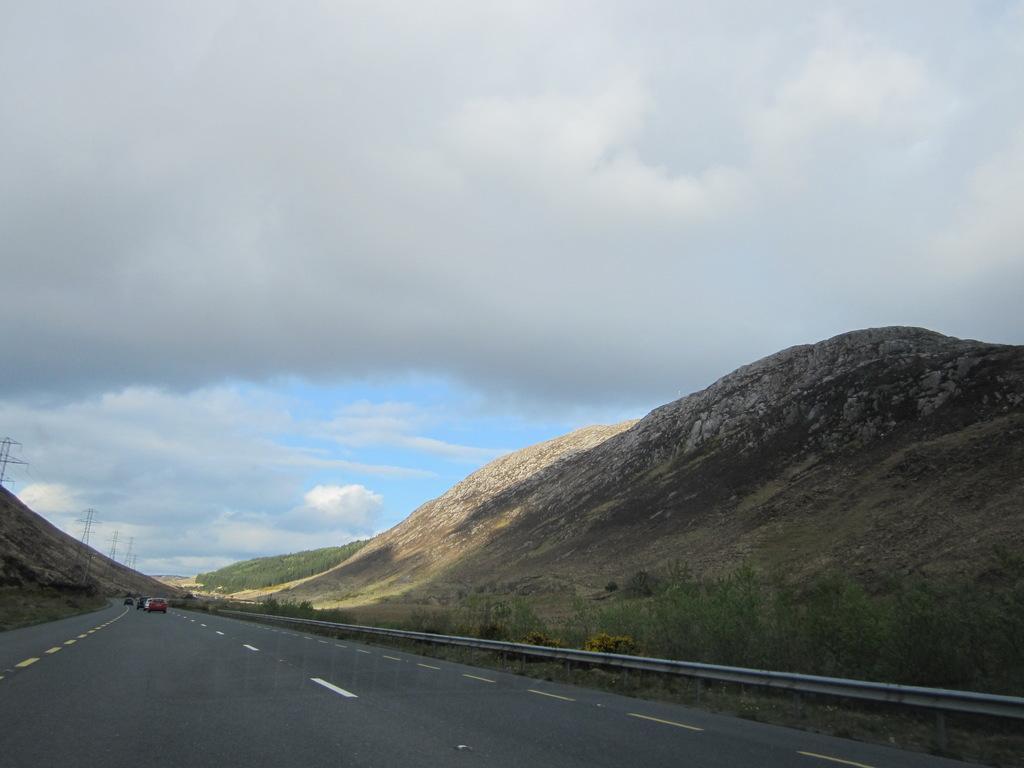In one or two sentences, can you explain what this image depicts? In this picture we can see vehicles on the road, fence, plants, mountains, towers and in the background we can see the sky with clouds. 